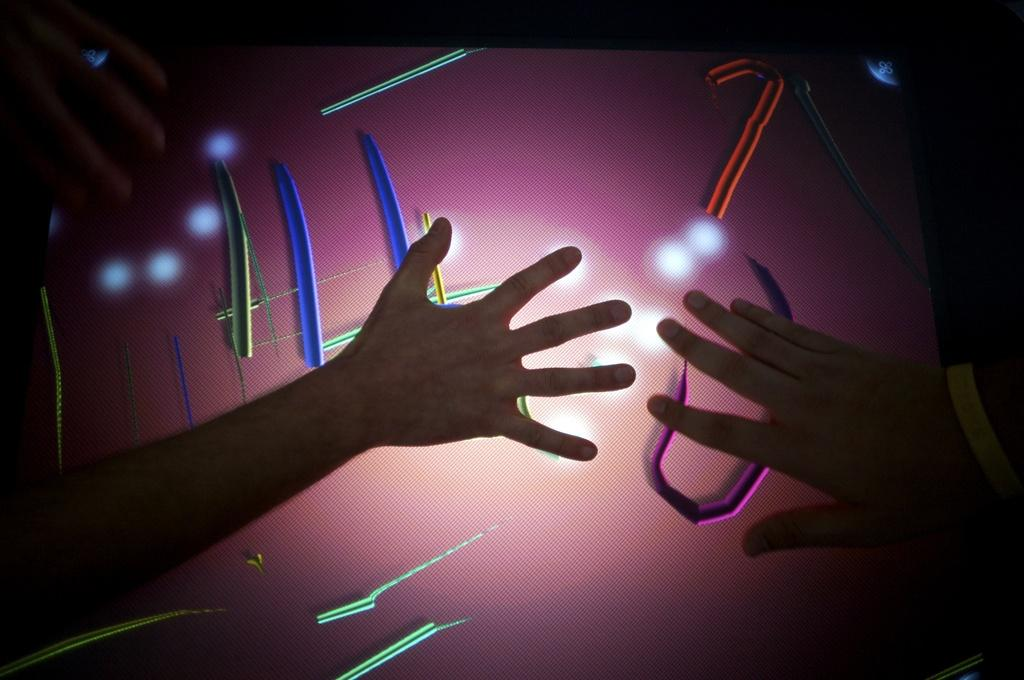Who or what is the main subject in the image? There is a person in the image. What is the person doing in the image? The person's hands are touching a pink object. What color is the background of the image? The background of the image is black. Are the person's friends in the image? There is no information about friends in the image, so we cannot determine if they are present or not. 